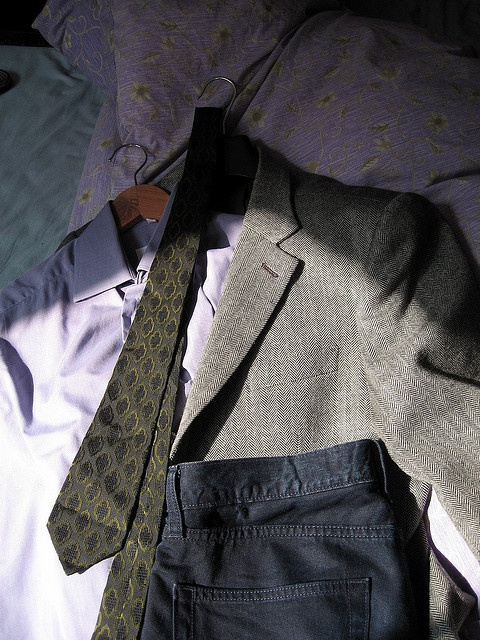Describe the objects in this image and their specific colors. I can see tie in black, gray, darkgreen, and olive tones and bed in black, blue, and darkblue tones in this image. 